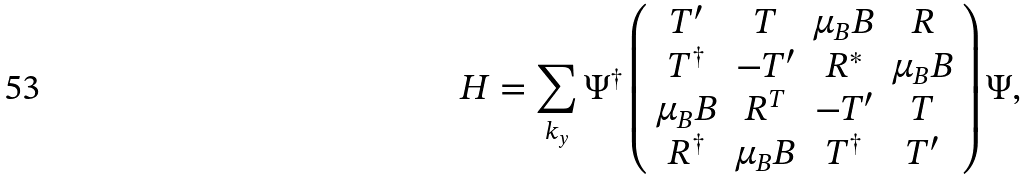<formula> <loc_0><loc_0><loc_500><loc_500>H = \sum _ { k _ { y } } \Psi ^ { \dag } \left ( \begin{array} { c c c c } T ^ { \prime } & T & \mu _ { B } B & R \\ T ^ { \dagger } & - T ^ { \prime } & R ^ { * } & \mu _ { B } B \\ \mu _ { B } B & R ^ { T } & - T ^ { \prime } & T \\ R ^ { \dagger } & \mu _ { B } B & T ^ { \dagger } & T ^ { \prime } \end{array} \right ) \Psi ,</formula> 